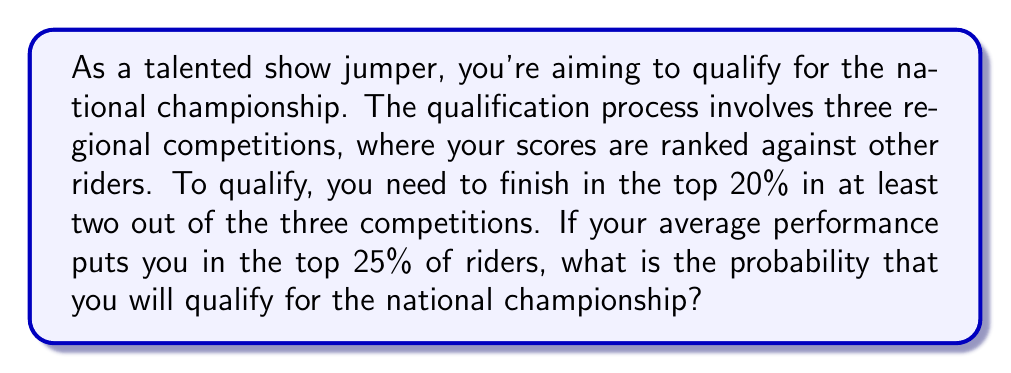Give your solution to this math problem. Let's approach this step-by-step:

1) First, we need to calculate the probability of finishing in the top 20% in a single competition, given that your average performance is in the top 25%.

   Let's call the event of finishing in the top 20% as A, and being in the top 25% on average as B.
   We want to find P(A|B), which can be approximated as P(A|B) ≈ 0.8

   This is because if you're in the top 25% on average, you're likely to finish in the top 20% about 80% of the time.

2) Now, we need to calculate the probability of qualifying, which means finishing in the top 20% in at least 2 out of 3 competitions.

3) We can use the binomial probability formula for this:

   $$P(X \geq 2) = P(X=2) + P(X=3)$$

   where X is the number of successes (finishing in top 20%) in 3 trials.

4) The probability of exactly 2 successes in 3 trials is:

   $$P(X=2) = \binom{3}{2} * 0.8^2 * 0.2^1 = 3 * 0.64 * 0.2 = 0.384$$

5) The probability of 3 successes in 3 trials is:

   $$P(X=3) = \binom{3}{3} * 0.8^3 * 0.2^0 = 1 * 0.512 * 1 = 0.512$$

6) Therefore, the total probability of qualifying is:

   $$P(X \geq 2) = 0.384 + 0.512 = 0.896$$
Answer: The probability of qualifying for the national championship is approximately 0.896 or 89.6%. 